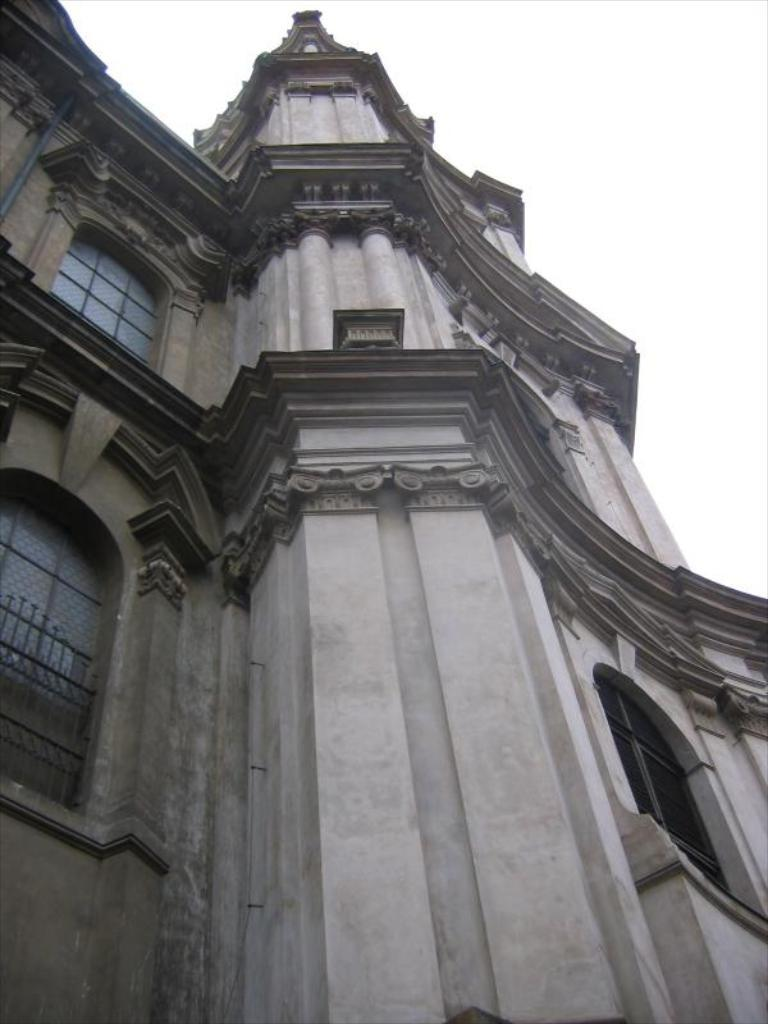What structure is present in the image? There is a building in the image. What feature can be observed on the building? The building has windows. What is visible at the top of the image? The sky is visible at the top of the image. What type of toothpaste is being used to adjust the building in the image? There is no toothpaste or adjustment being made to the building in the image; it is a static structure. What type of fork can be seen in the image? There is no fork present in the image. 